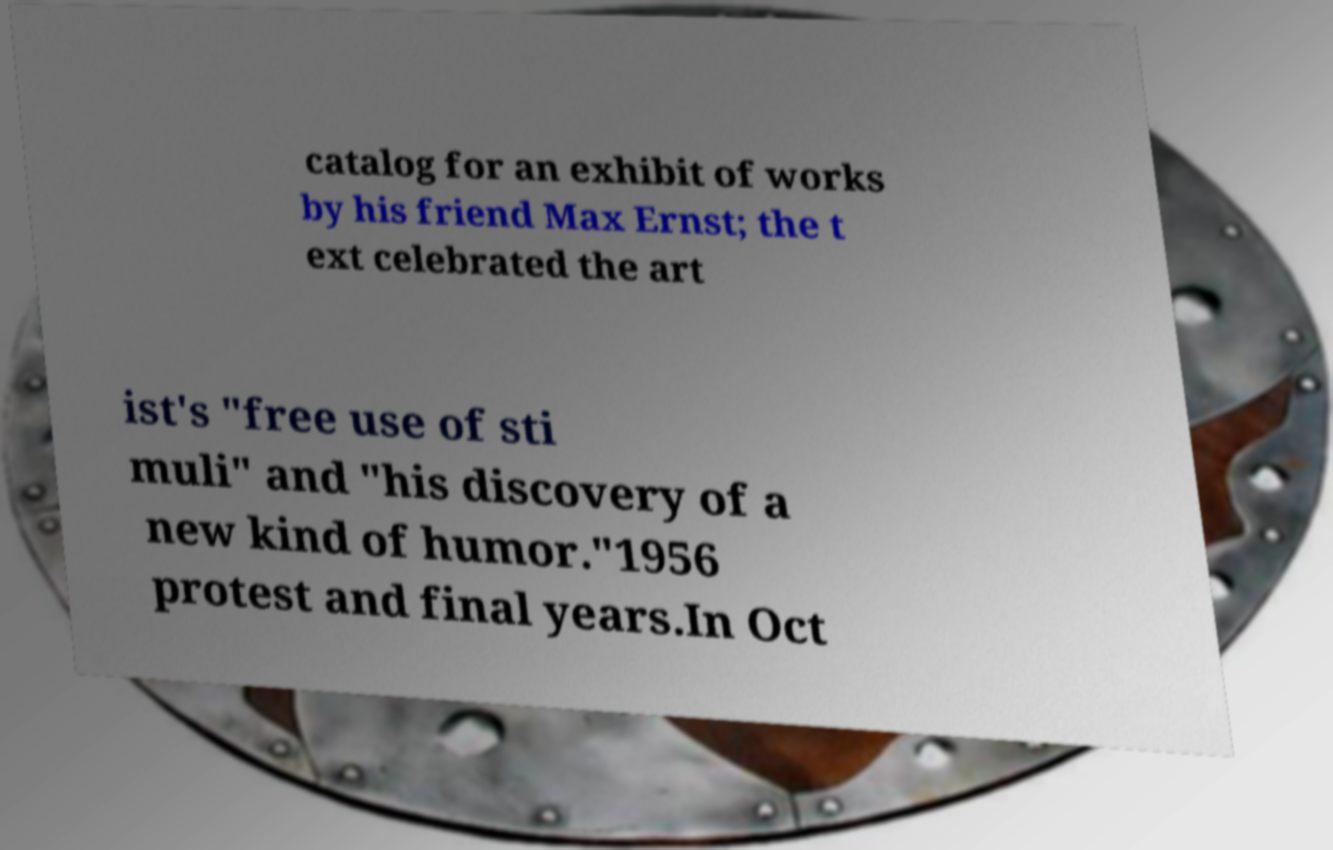Please identify and transcribe the text found in this image. catalog for an exhibit of works by his friend Max Ernst; the t ext celebrated the art ist's "free use of sti muli" and "his discovery of a new kind of humor."1956 protest and final years.In Oct 